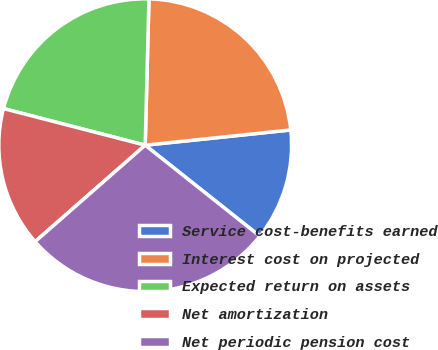<chart> <loc_0><loc_0><loc_500><loc_500><pie_chart><fcel>Service cost-benefits earned<fcel>Interest cost on projected<fcel>Expected return on assets<fcel>Net amortization<fcel>Net periodic pension cost<nl><fcel>12.34%<fcel>22.93%<fcel>21.38%<fcel>15.48%<fcel>27.87%<nl></chart> 